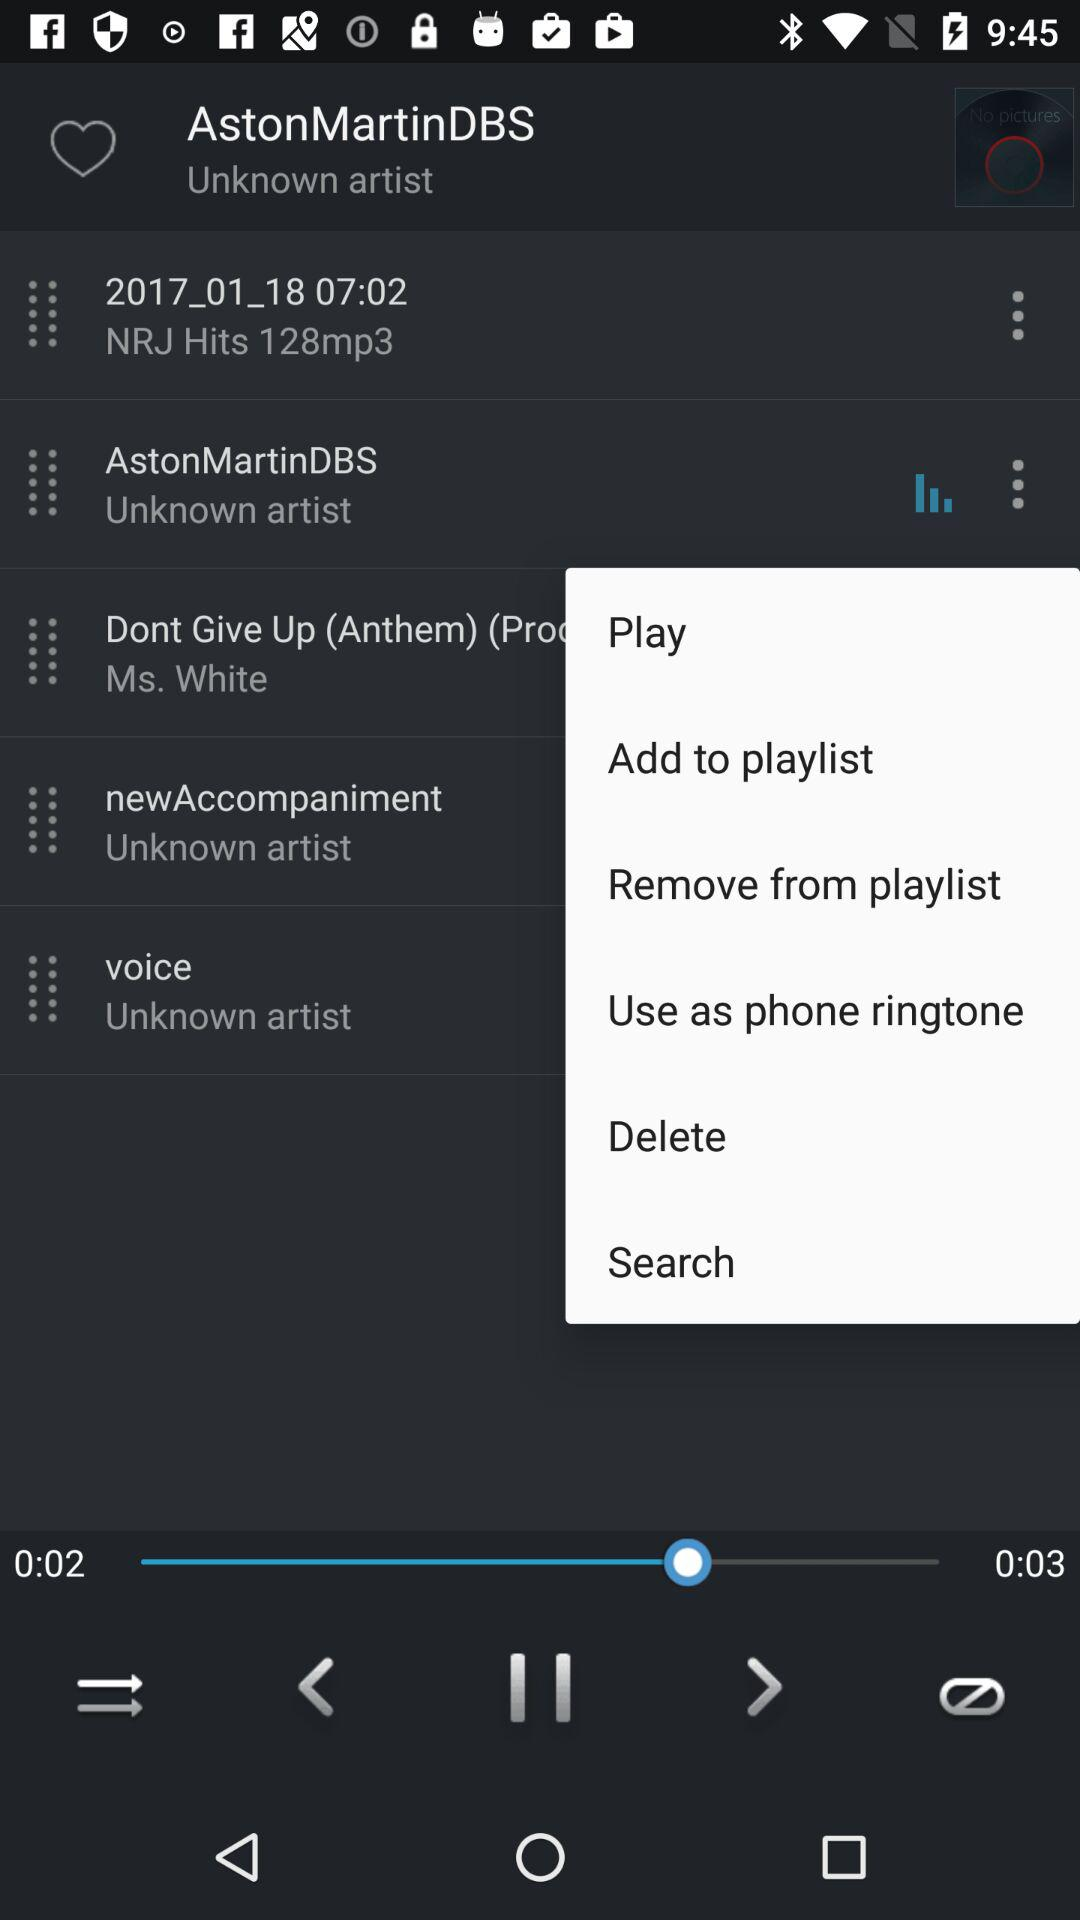Which audio is playing? The audio that is playing is "AstonMartinDBS". 